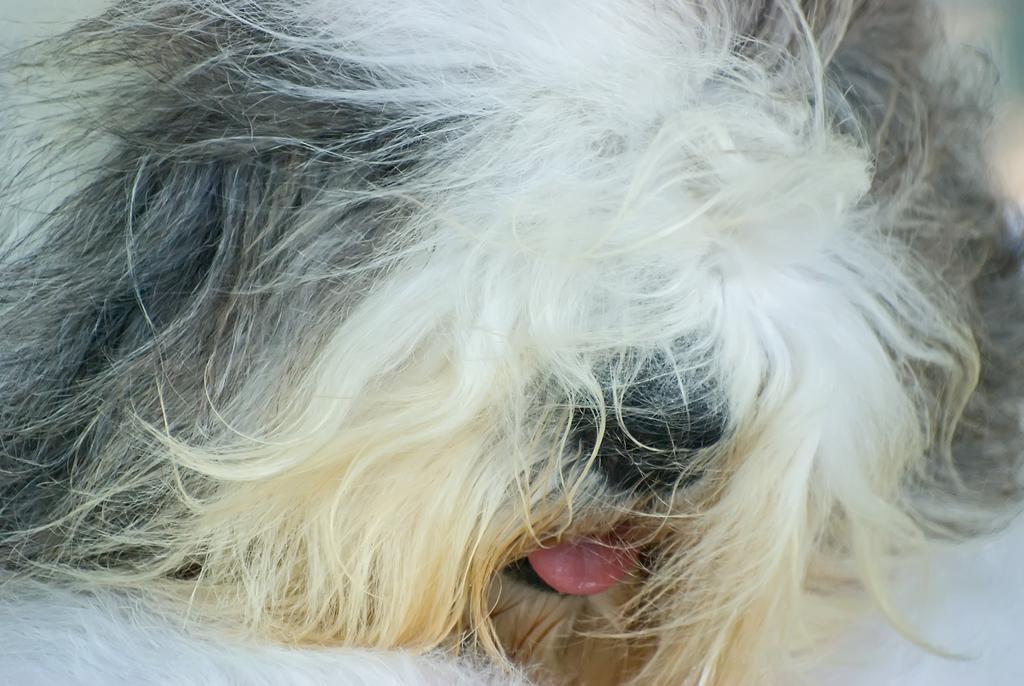In one or two sentences, can you explain what this image depicts? In this image, we can see a dog lying on the floor. 